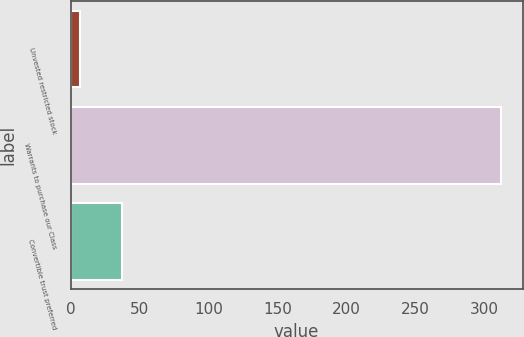<chart> <loc_0><loc_0><loc_500><loc_500><bar_chart><fcel>Unvested restricted stock<fcel>Warrants to purchase our Class<fcel>Convertible trust preferred<nl><fcel>7<fcel>312<fcel>37.5<nl></chart> 